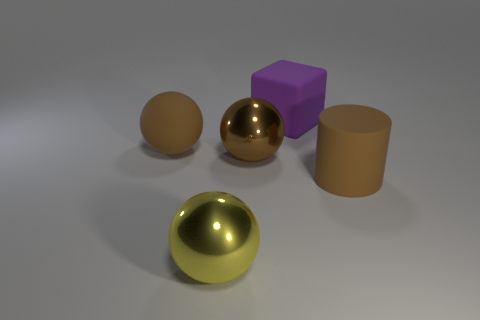Subtract all yellow spheres. How many spheres are left? 2 Add 1 big brown cylinders. How many objects exist? 6 Subtract all rubber spheres. How many spheres are left? 2 Add 5 big cylinders. How many big cylinders are left? 6 Add 2 big blue metal objects. How many big blue metal objects exist? 2 Subtract 0 gray cylinders. How many objects are left? 5 Subtract all spheres. How many objects are left? 2 Subtract 1 cubes. How many cubes are left? 0 Subtract all red spheres. Subtract all red cylinders. How many spheres are left? 3 Subtract all blue cylinders. How many yellow balls are left? 1 